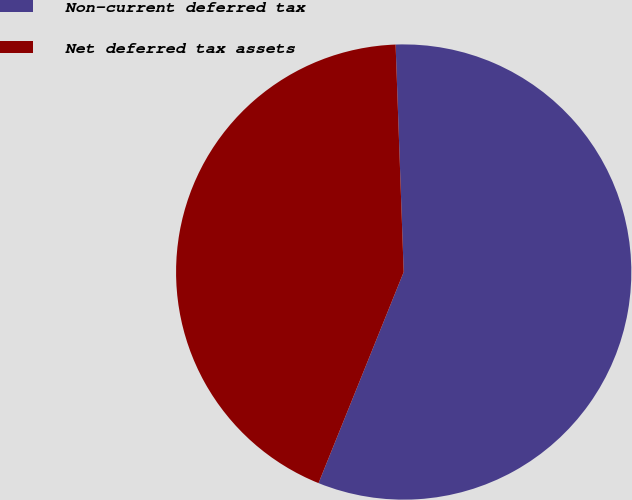Convert chart. <chart><loc_0><loc_0><loc_500><loc_500><pie_chart><fcel>Non-current deferred tax<fcel>Net deferred tax assets<nl><fcel>56.67%<fcel>43.33%<nl></chart> 